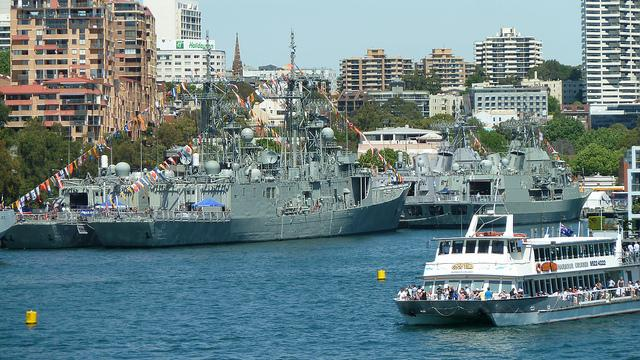What vehicle used for this water transportation? ship 